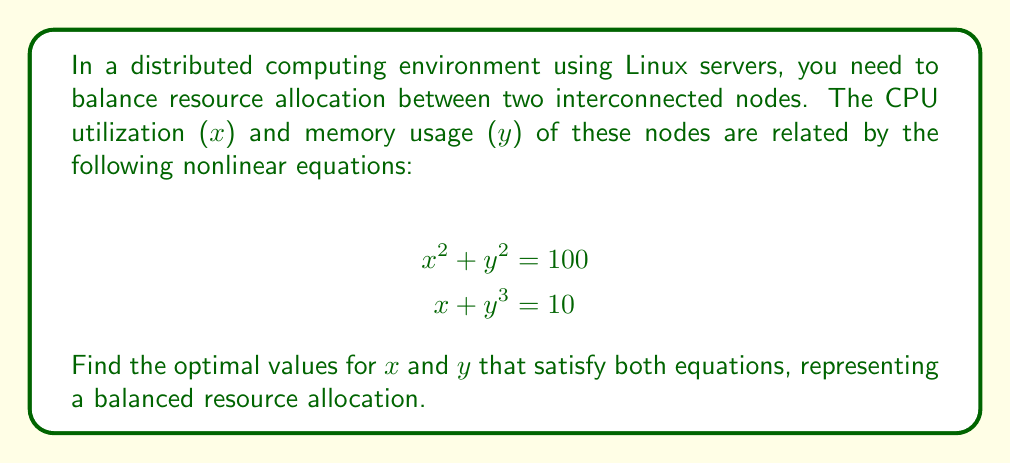Could you help me with this problem? To solve this system of nonlinear equations, we'll use the substitution method:

1) From the second equation, express $x$ in terms of $y$:
   $x = 10 - y^3$

2) Substitute this expression into the first equation:
   $(10 - y^3)^2 + y^2 = 100$

3) Expand the squared term:
   $100 - 20y^3 + y^6 + y^2 = 100$

4) Simplify:
   $y^6 - 20y^3 + y^2 = 0$

5) This is a cubic equation in $y^2$. Let $u = y^2$:
   $u^3 - 20u^{3/2} + u = 0$

6) Factor out $u$:
   $u(u^2 - 20u^{1/2} + 1) = 0$

7) Solve for $u$:
   $u = 0$ or $u^2 - 20u^{1/2} + 1 = 0$

8) $u = 0$ is not a valid solution as it would make $y = 0$ and $x = 10$, which doesn't satisfy the original equations.

9) For $u^2 - 20u^{1/2} + 1 = 0$, let $v = u^{1/2}$:
   $v^4 - 20v + 1 = 0$

10) This quartic equation can be solved numerically. The positive real solution is approximately:
    $v ≈ 3.86619826153115$

11) Therefore, $u = v^2 ≈ 14.9475$

12) Since $u = y^2$, $y = \sqrt{14.9475} ≈ 3.8662$

13) Substitute this value of $y$ into $x = 10 - y^3$:
    $x ≈ 10 - 3.8662^3 ≈ 8.2175$

14) Verify that these values satisfy both original equations:
    $8.2175^2 + 3.8662^2 ≈ 100$
    $8.2175 + 3.8662^3 ≈ 10$
Answer: $x ≈ 8.2175$, $y ≈ 3.8662$ 